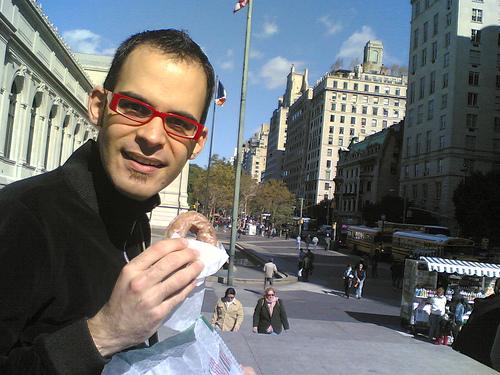What type of people do the buses visible just behind the food stand transport?
Keep it brief. Students. What is the man holding?
Concise answer only. Donut. Is it likely to rain in the next few minutes?
Be succinct. No. 